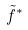<formula> <loc_0><loc_0><loc_500><loc_500>\tilde { f } ^ { * }</formula> 